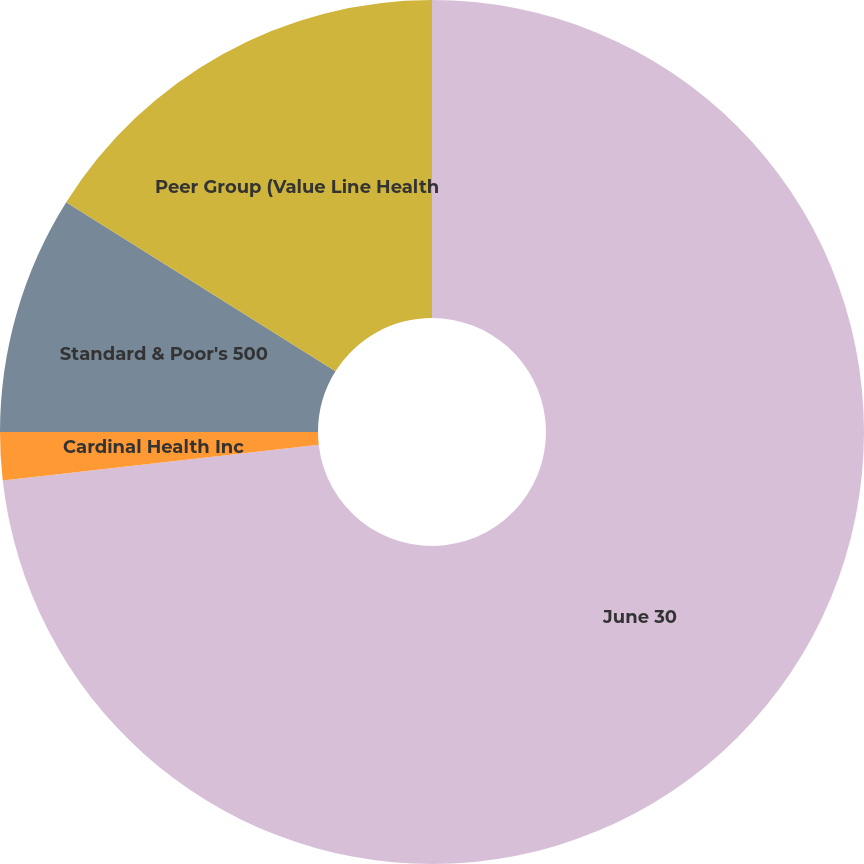Convert chart to OTSL. <chart><loc_0><loc_0><loc_500><loc_500><pie_chart><fcel>June 30<fcel>Cardinal Health Inc<fcel>Standard & Poor's 500<fcel>Peer Group (Value Line Health<nl><fcel>73.21%<fcel>1.79%<fcel>8.93%<fcel>16.07%<nl></chart> 